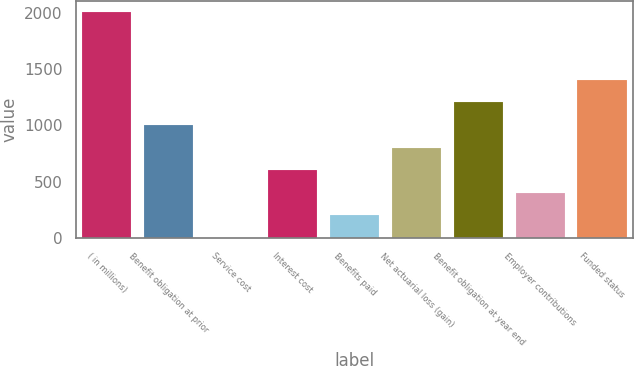Convert chart to OTSL. <chart><loc_0><loc_0><loc_500><loc_500><bar_chart><fcel>( in millions)<fcel>Benefit obligation at prior<fcel>Service cost<fcel>Interest cost<fcel>Benefits paid<fcel>Net actuarial loss (gain)<fcel>Benefit obligation at year end<fcel>Employer contributions<fcel>Funded status<nl><fcel>2006<fcel>1004.65<fcel>3.3<fcel>604.11<fcel>203.57<fcel>804.38<fcel>1204.92<fcel>403.84<fcel>1405.19<nl></chart> 